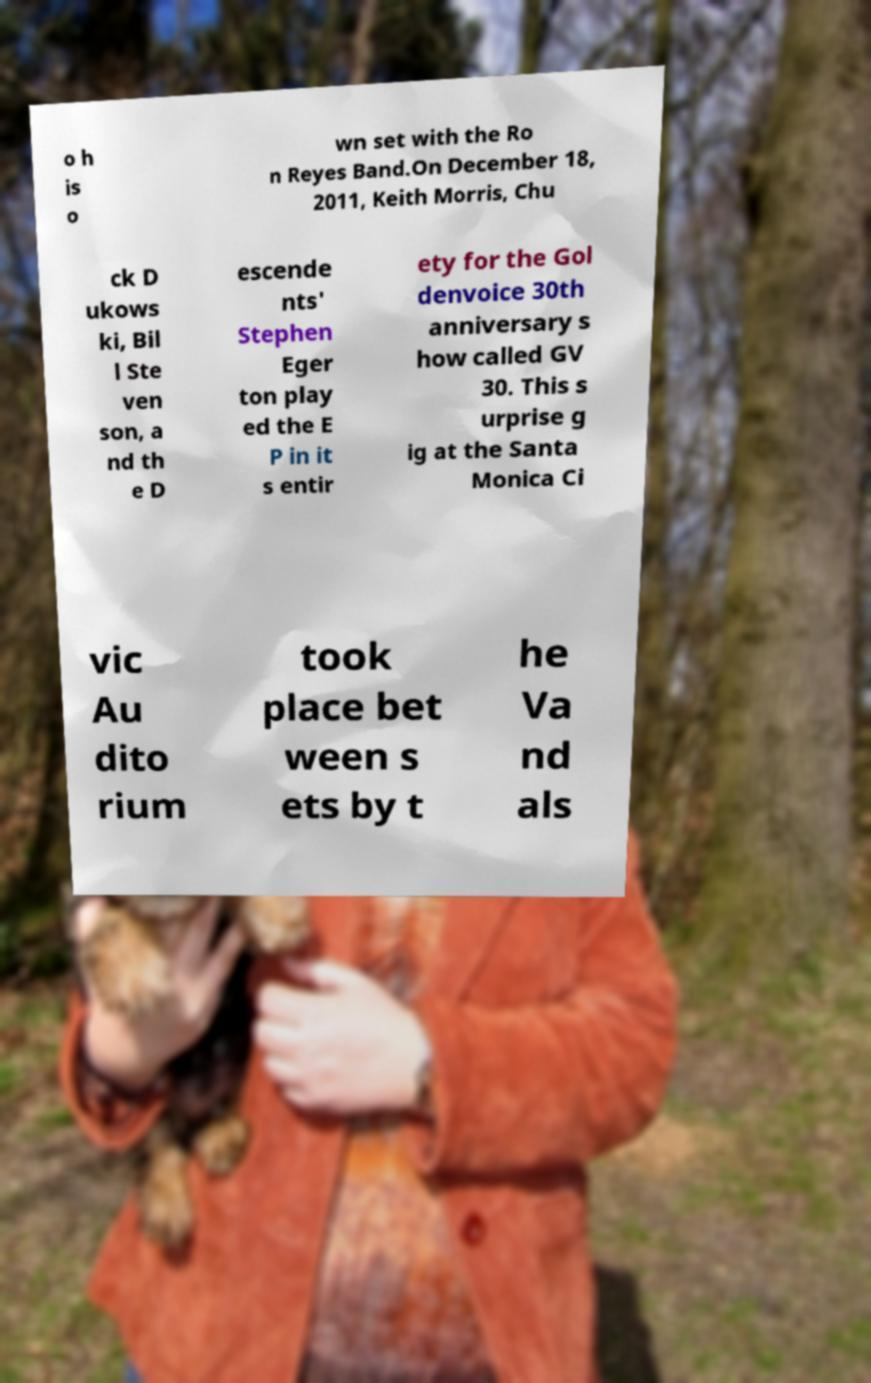Could you extract and type out the text from this image? o h is o wn set with the Ro n Reyes Band.On December 18, 2011, Keith Morris, Chu ck D ukows ki, Bil l Ste ven son, a nd th e D escende nts' Stephen Eger ton play ed the E P in it s entir ety for the Gol denvoice 30th anniversary s how called GV 30. This s urprise g ig at the Santa Monica Ci vic Au dito rium took place bet ween s ets by t he Va nd als 